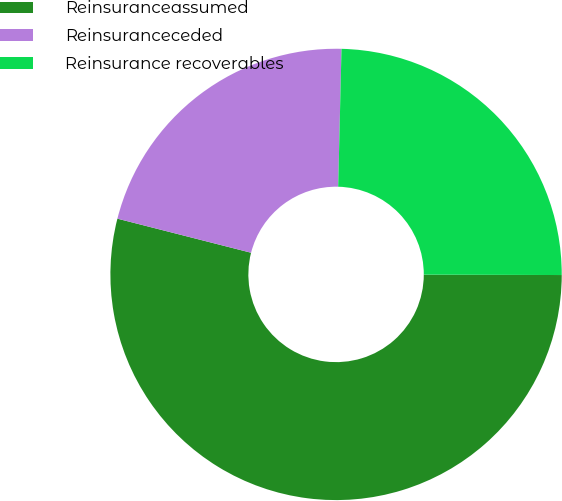<chart> <loc_0><loc_0><loc_500><loc_500><pie_chart><fcel>Reinsuranceassumed<fcel>Reinsuranceceded<fcel>Reinsurance recoverables<nl><fcel>53.93%<fcel>21.41%<fcel>24.66%<nl></chart> 